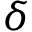<formula> <loc_0><loc_0><loc_500><loc_500>\delta</formula> 